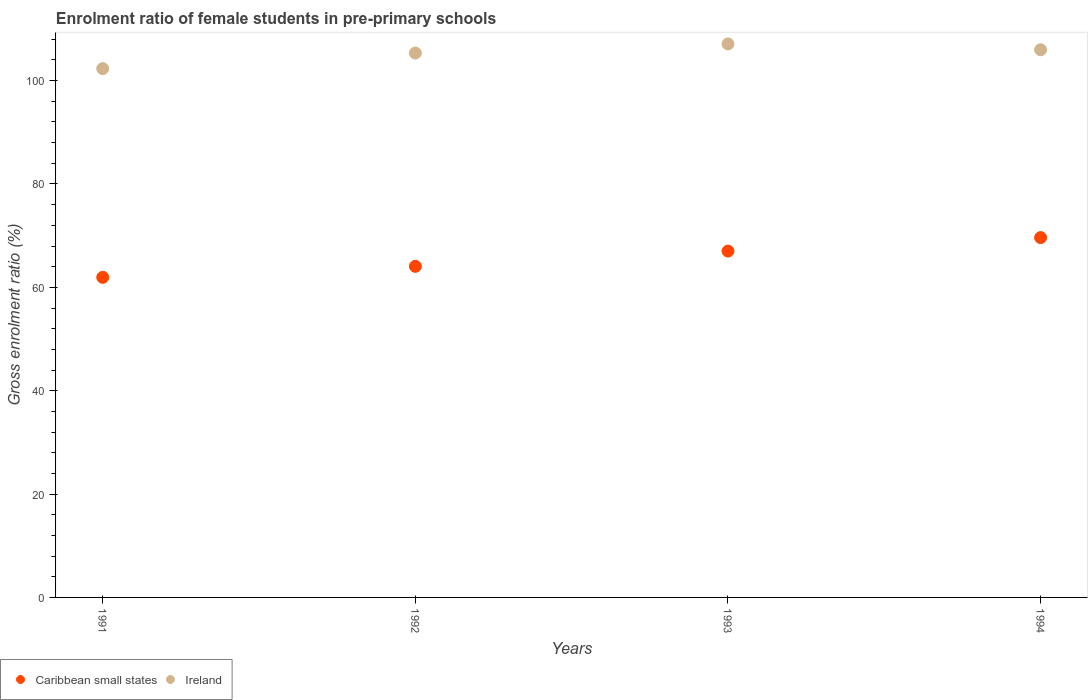How many different coloured dotlines are there?
Your answer should be very brief. 2. What is the enrolment ratio of female students in pre-primary schools in Caribbean small states in 1994?
Offer a very short reply. 69.63. Across all years, what is the maximum enrolment ratio of female students in pre-primary schools in Ireland?
Your response must be concise. 107.11. Across all years, what is the minimum enrolment ratio of female students in pre-primary schools in Ireland?
Your response must be concise. 102.32. In which year was the enrolment ratio of female students in pre-primary schools in Caribbean small states minimum?
Give a very brief answer. 1991. What is the total enrolment ratio of female students in pre-primary schools in Caribbean small states in the graph?
Your response must be concise. 262.65. What is the difference between the enrolment ratio of female students in pre-primary schools in Caribbean small states in 1992 and that in 1994?
Make the answer very short. -5.57. What is the difference between the enrolment ratio of female students in pre-primary schools in Caribbean small states in 1993 and the enrolment ratio of female students in pre-primary schools in Ireland in 1994?
Give a very brief answer. -38.96. What is the average enrolment ratio of female students in pre-primary schools in Caribbean small states per year?
Provide a succinct answer. 65.66. In the year 1994, what is the difference between the enrolment ratio of female students in pre-primary schools in Caribbean small states and enrolment ratio of female students in pre-primary schools in Ireland?
Provide a succinct answer. -36.35. In how many years, is the enrolment ratio of female students in pre-primary schools in Ireland greater than 100 %?
Give a very brief answer. 4. What is the ratio of the enrolment ratio of female students in pre-primary schools in Ireland in 1991 to that in 1992?
Offer a very short reply. 0.97. Is the difference between the enrolment ratio of female students in pre-primary schools in Caribbean small states in 1991 and 1993 greater than the difference between the enrolment ratio of female students in pre-primary schools in Ireland in 1991 and 1993?
Provide a succinct answer. No. What is the difference between the highest and the second highest enrolment ratio of female students in pre-primary schools in Caribbean small states?
Make the answer very short. 2.61. What is the difference between the highest and the lowest enrolment ratio of female students in pre-primary schools in Ireland?
Give a very brief answer. 4.78. In how many years, is the enrolment ratio of female students in pre-primary schools in Ireland greater than the average enrolment ratio of female students in pre-primary schools in Ireland taken over all years?
Ensure brevity in your answer.  3. Is the enrolment ratio of female students in pre-primary schools in Ireland strictly greater than the enrolment ratio of female students in pre-primary schools in Caribbean small states over the years?
Offer a very short reply. Yes. How many dotlines are there?
Your answer should be very brief. 2. Are the values on the major ticks of Y-axis written in scientific E-notation?
Provide a short and direct response. No. How many legend labels are there?
Offer a terse response. 2. How are the legend labels stacked?
Your answer should be very brief. Horizontal. What is the title of the graph?
Provide a succinct answer. Enrolment ratio of female students in pre-primary schools. Does "Barbados" appear as one of the legend labels in the graph?
Ensure brevity in your answer.  No. What is the Gross enrolment ratio (%) of Caribbean small states in 1991?
Make the answer very short. 61.94. What is the Gross enrolment ratio (%) of Ireland in 1991?
Ensure brevity in your answer.  102.32. What is the Gross enrolment ratio (%) in Caribbean small states in 1992?
Provide a succinct answer. 64.06. What is the Gross enrolment ratio (%) in Ireland in 1992?
Provide a succinct answer. 105.34. What is the Gross enrolment ratio (%) of Caribbean small states in 1993?
Keep it short and to the point. 67.02. What is the Gross enrolment ratio (%) of Ireland in 1993?
Ensure brevity in your answer.  107.11. What is the Gross enrolment ratio (%) in Caribbean small states in 1994?
Give a very brief answer. 69.63. What is the Gross enrolment ratio (%) of Ireland in 1994?
Offer a very short reply. 105.98. Across all years, what is the maximum Gross enrolment ratio (%) of Caribbean small states?
Provide a short and direct response. 69.63. Across all years, what is the maximum Gross enrolment ratio (%) in Ireland?
Give a very brief answer. 107.11. Across all years, what is the minimum Gross enrolment ratio (%) of Caribbean small states?
Ensure brevity in your answer.  61.94. Across all years, what is the minimum Gross enrolment ratio (%) in Ireland?
Keep it short and to the point. 102.32. What is the total Gross enrolment ratio (%) of Caribbean small states in the graph?
Give a very brief answer. 262.65. What is the total Gross enrolment ratio (%) of Ireland in the graph?
Offer a very short reply. 420.74. What is the difference between the Gross enrolment ratio (%) in Caribbean small states in 1991 and that in 1992?
Your answer should be compact. -2.13. What is the difference between the Gross enrolment ratio (%) of Ireland in 1991 and that in 1992?
Give a very brief answer. -3.02. What is the difference between the Gross enrolment ratio (%) in Caribbean small states in 1991 and that in 1993?
Your response must be concise. -5.08. What is the difference between the Gross enrolment ratio (%) in Ireland in 1991 and that in 1993?
Your answer should be very brief. -4.78. What is the difference between the Gross enrolment ratio (%) in Caribbean small states in 1991 and that in 1994?
Give a very brief answer. -7.69. What is the difference between the Gross enrolment ratio (%) of Ireland in 1991 and that in 1994?
Keep it short and to the point. -3.65. What is the difference between the Gross enrolment ratio (%) in Caribbean small states in 1992 and that in 1993?
Ensure brevity in your answer.  -2.95. What is the difference between the Gross enrolment ratio (%) in Ireland in 1992 and that in 1993?
Give a very brief answer. -1.76. What is the difference between the Gross enrolment ratio (%) in Caribbean small states in 1992 and that in 1994?
Give a very brief answer. -5.57. What is the difference between the Gross enrolment ratio (%) in Ireland in 1992 and that in 1994?
Give a very brief answer. -0.64. What is the difference between the Gross enrolment ratio (%) of Caribbean small states in 1993 and that in 1994?
Keep it short and to the point. -2.61. What is the difference between the Gross enrolment ratio (%) in Ireland in 1993 and that in 1994?
Your response must be concise. 1.13. What is the difference between the Gross enrolment ratio (%) in Caribbean small states in 1991 and the Gross enrolment ratio (%) in Ireland in 1992?
Your answer should be very brief. -43.4. What is the difference between the Gross enrolment ratio (%) of Caribbean small states in 1991 and the Gross enrolment ratio (%) of Ireland in 1993?
Give a very brief answer. -45.17. What is the difference between the Gross enrolment ratio (%) of Caribbean small states in 1991 and the Gross enrolment ratio (%) of Ireland in 1994?
Provide a short and direct response. -44.04. What is the difference between the Gross enrolment ratio (%) in Caribbean small states in 1992 and the Gross enrolment ratio (%) in Ireland in 1993?
Provide a succinct answer. -43.04. What is the difference between the Gross enrolment ratio (%) of Caribbean small states in 1992 and the Gross enrolment ratio (%) of Ireland in 1994?
Your answer should be very brief. -41.91. What is the difference between the Gross enrolment ratio (%) in Caribbean small states in 1993 and the Gross enrolment ratio (%) in Ireland in 1994?
Your answer should be very brief. -38.96. What is the average Gross enrolment ratio (%) of Caribbean small states per year?
Your answer should be very brief. 65.66. What is the average Gross enrolment ratio (%) in Ireland per year?
Offer a very short reply. 105.19. In the year 1991, what is the difference between the Gross enrolment ratio (%) of Caribbean small states and Gross enrolment ratio (%) of Ireland?
Provide a short and direct response. -40.39. In the year 1992, what is the difference between the Gross enrolment ratio (%) in Caribbean small states and Gross enrolment ratio (%) in Ireland?
Your response must be concise. -41.28. In the year 1993, what is the difference between the Gross enrolment ratio (%) in Caribbean small states and Gross enrolment ratio (%) in Ireland?
Provide a succinct answer. -40.09. In the year 1994, what is the difference between the Gross enrolment ratio (%) of Caribbean small states and Gross enrolment ratio (%) of Ireland?
Give a very brief answer. -36.35. What is the ratio of the Gross enrolment ratio (%) of Caribbean small states in 1991 to that in 1992?
Offer a terse response. 0.97. What is the ratio of the Gross enrolment ratio (%) of Ireland in 1991 to that in 1992?
Ensure brevity in your answer.  0.97. What is the ratio of the Gross enrolment ratio (%) of Caribbean small states in 1991 to that in 1993?
Your answer should be compact. 0.92. What is the ratio of the Gross enrolment ratio (%) in Ireland in 1991 to that in 1993?
Offer a terse response. 0.96. What is the ratio of the Gross enrolment ratio (%) in Caribbean small states in 1991 to that in 1994?
Ensure brevity in your answer.  0.89. What is the ratio of the Gross enrolment ratio (%) in Ireland in 1991 to that in 1994?
Provide a short and direct response. 0.97. What is the ratio of the Gross enrolment ratio (%) in Caribbean small states in 1992 to that in 1993?
Provide a succinct answer. 0.96. What is the ratio of the Gross enrolment ratio (%) of Ireland in 1992 to that in 1993?
Ensure brevity in your answer.  0.98. What is the ratio of the Gross enrolment ratio (%) in Caribbean small states in 1992 to that in 1994?
Provide a short and direct response. 0.92. What is the ratio of the Gross enrolment ratio (%) in Ireland in 1992 to that in 1994?
Give a very brief answer. 0.99. What is the ratio of the Gross enrolment ratio (%) in Caribbean small states in 1993 to that in 1994?
Give a very brief answer. 0.96. What is the ratio of the Gross enrolment ratio (%) of Ireland in 1993 to that in 1994?
Give a very brief answer. 1.01. What is the difference between the highest and the second highest Gross enrolment ratio (%) in Caribbean small states?
Your response must be concise. 2.61. What is the difference between the highest and the second highest Gross enrolment ratio (%) in Ireland?
Your answer should be very brief. 1.13. What is the difference between the highest and the lowest Gross enrolment ratio (%) in Caribbean small states?
Make the answer very short. 7.69. What is the difference between the highest and the lowest Gross enrolment ratio (%) of Ireland?
Your answer should be very brief. 4.78. 